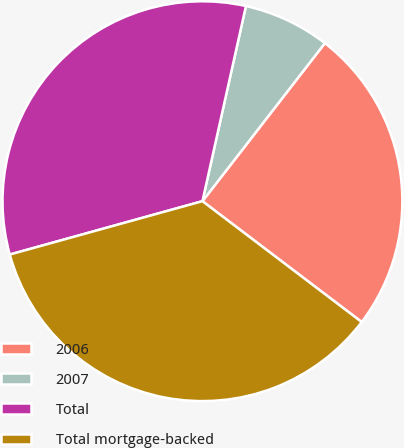Convert chart. <chart><loc_0><loc_0><loc_500><loc_500><pie_chart><fcel>2006<fcel>2007<fcel>Total<fcel>Total mortgage-backed<nl><fcel>24.84%<fcel>7.0%<fcel>32.79%<fcel>35.37%<nl></chart> 